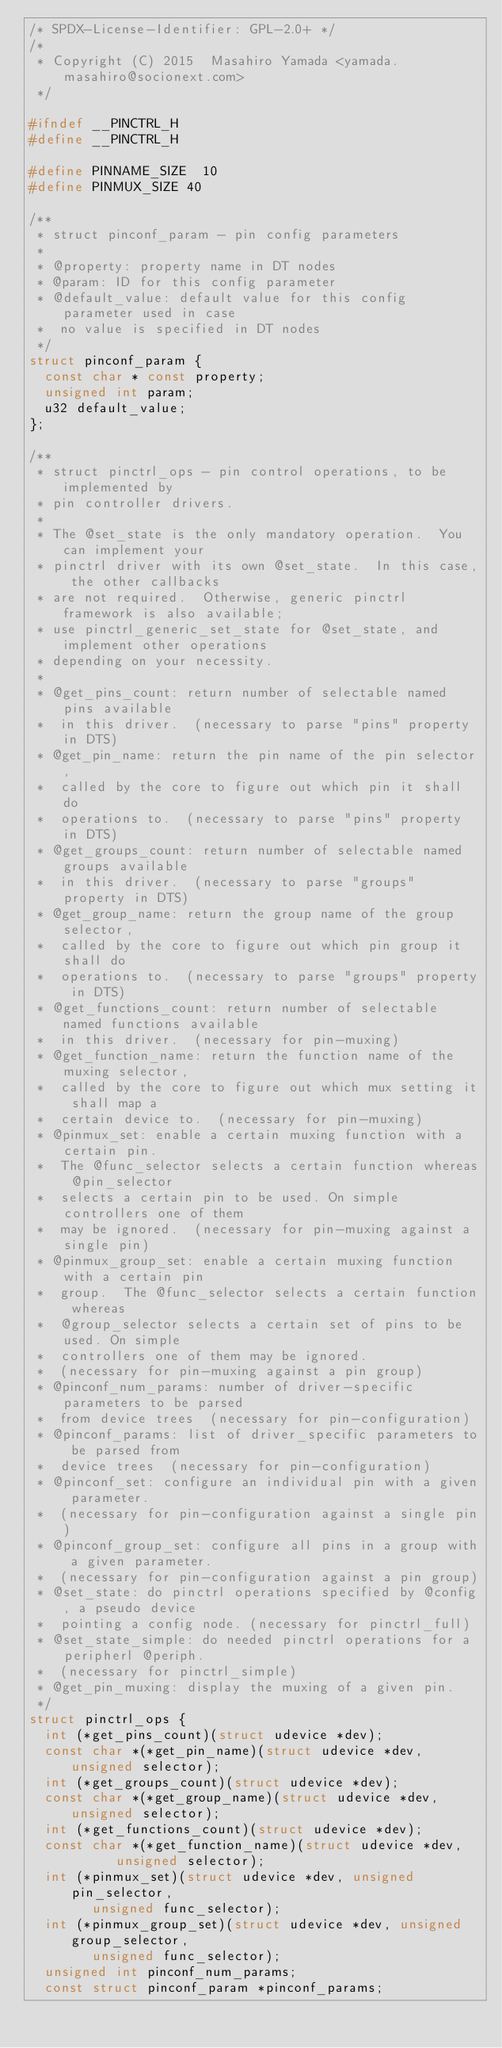Convert code to text. <code><loc_0><loc_0><loc_500><loc_500><_C_>/* SPDX-License-Identifier: GPL-2.0+ */
/*
 * Copyright (C) 2015  Masahiro Yamada <yamada.masahiro@socionext.com>
 */

#ifndef __PINCTRL_H
#define __PINCTRL_H

#define PINNAME_SIZE	10
#define PINMUX_SIZE	40

/**
 * struct pinconf_param - pin config parameters
 *
 * @property: property name in DT nodes
 * @param: ID for this config parameter
 * @default_value: default value for this config parameter used in case
 *	no value is specified in DT nodes
 */
struct pinconf_param {
	const char * const property;
	unsigned int param;
	u32 default_value;
};

/**
 * struct pinctrl_ops - pin control operations, to be implemented by
 * pin controller drivers.
 *
 * The @set_state is the only mandatory operation.  You can implement your
 * pinctrl driver with its own @set_state.  In this case, the other callbacks
 * are not required.  Otherwise, generic pinctrl framework is also available;
 * use pinctrl_generic_set_state for @set_state, and implement other operations
 * depending on your necessity.
 *
 * @get_pins_count: return number of selectable named pins available
 *	in this driver.  (necessary to parse "pins" property in DTS)
 * @get_pin_name: return the pin name of the pin selector,
 *	called by the core to figure out which pin it shall do
 *	operations to.  (necessary to parse "pins" property in DTS)
 * @get_groups_count: return number of selectable named groups available
 *	in this driver.  (necessary to parse "groups" property in DTS)
 * @get_group_name: return the group name of the group selector,
 *	called by the core to figure out which pin group it shall do
 *	operations to.  (necessary to parse "groups" property in DTS)
 * @get_functions_count: return number of selectable named functions available
 *	in this driver.  (necessary for pin-muxing)
 * @get_function_name: return the function name of the muxing selector,
 *	called by the core to figure out which mux setting it shall map a
 *	certain device to.  (necessary for pin-muxing)
 * @pinmux_set: enable a certain muxing function with a certain pin.
 *	The @func_selector selects a certain function whereas @pin_selector
 *	selects a certain pin to be used. On simple controllers one of them
 *	may be ignored.  (necessary for pin-muxing against a single pin)
 * @pinmux_group_set: enable a certain muxing function with a certain pin
 *	group.  The @func_selector selects a certain function whereas
 *	@group_selector selects a certain set of pins to be used. On simple
 *	controllers one of them may be ignored.
 *	(necessary for pin-muxing against a pin group)
 * @pinconf_num_params: number of driver-specific parameters to be parsed
 *	from device trees  (necessary for pin-configuration)
 * @pinconf_params: list of driver_specific parameters to be parsed from
 *	device trees  (necessary for pin-configuration)
 * @pinconf_set: configure an individual pin with a given parameter.
 *	(necessary for pin-configuration against a single pin)
 * @pinconf_group_set: configure all pins in a group with a given parameter.
 *	(necessary for pin-configuration against a pin group)
 * @set_state: do pinctrl operations specified by @config, a pseudo device
 *	pointing a config node. (necessary for pinctrl_full)
 * @set_state_simple: do needed pinctrl operations for a peripherl @periph.
 *	(necessary for pinctrl_simple)
 * @get_pin_muxing: display the muxing of a given pin.
 */
struct pinctrl_ops {
	int (*get_pins_count)(struct udevice *dev);
	const char *(*get_pin_name)(struct udevice *dev, unsigned selector);
	int (*get_groups_count)(struct udevice *dev);
	const char *(*get_group_name)(struct udevice *dev, unsigned selector);
	int (*get_functions_count)(struct udevice *dev);
	const char *(*get_function_name)(struct udevice *dev,
					 unsigned selector);
	int (*pinmux_set)(struct udevice *dev, unsigned pin_selector,
			  unsigned func_selector);
	int (*pinmux_group_set)(struct udevice *dev, unsigned group_selector,
				unsigned func_selector);
	unsigned int pinconf_num_params;
	const struct pinconf_param *pinconf_params;</code> 